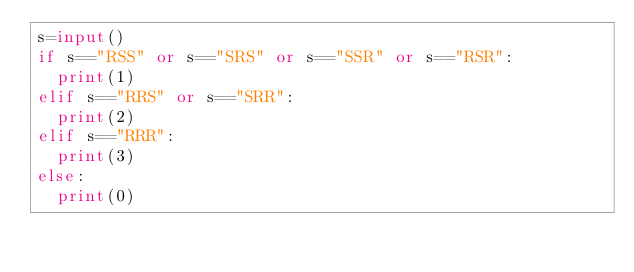<code> <loc_0><loc_0><loc_500><loc_500><_Python_>s=input()
if s=="RSS" or s=="SRS" or s=="SSR" or s=="RSR":
  print(1)
elif s=="RRS" or s=="SRR":
  print(2)
elif s=="RRR":
  print(3)
else:
  print(0)</code> 